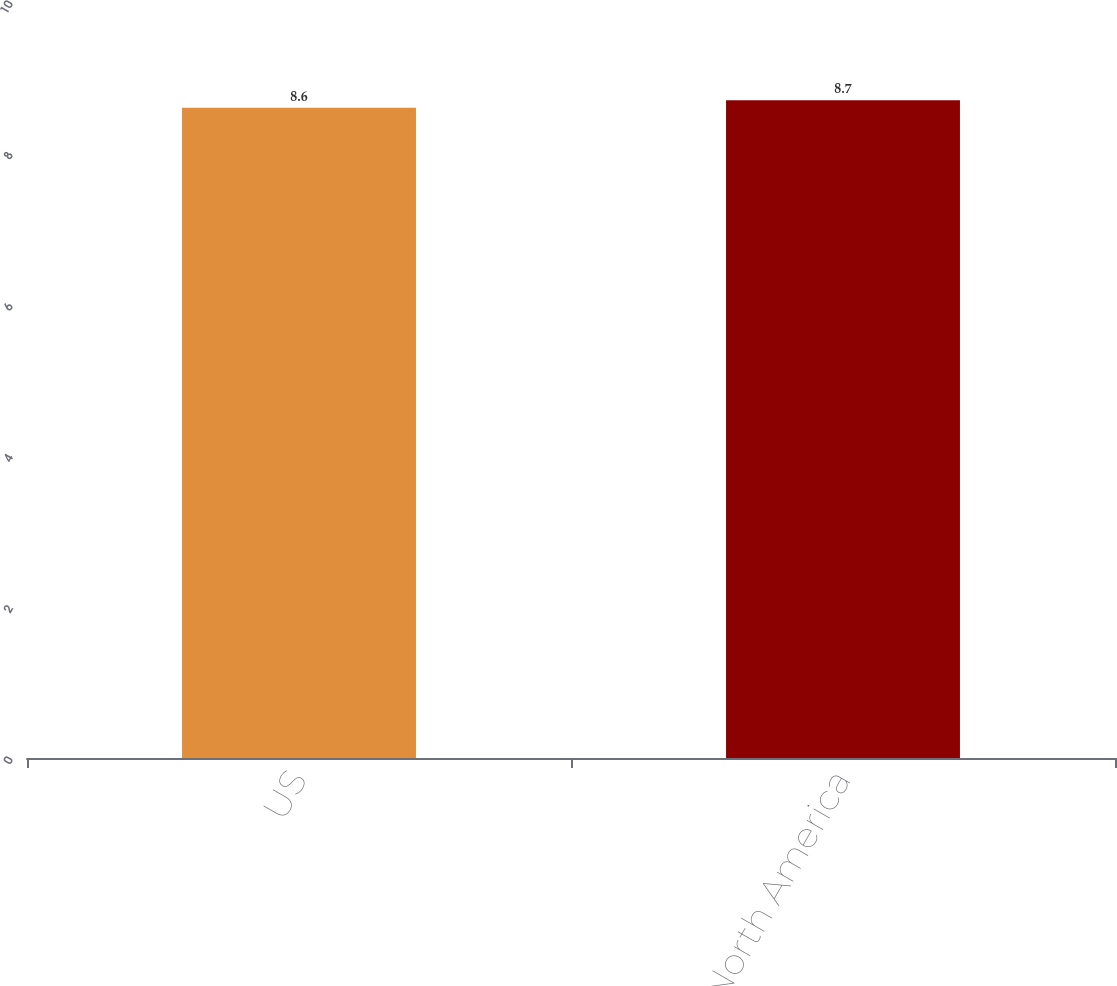Convert chart. <chart><loc_0><loc_0><loc_500><loc_500><bar_chart><fcel>US<fcel>Total North America<nl><fcel>8.6<fcel>8.7<nl></chart> 